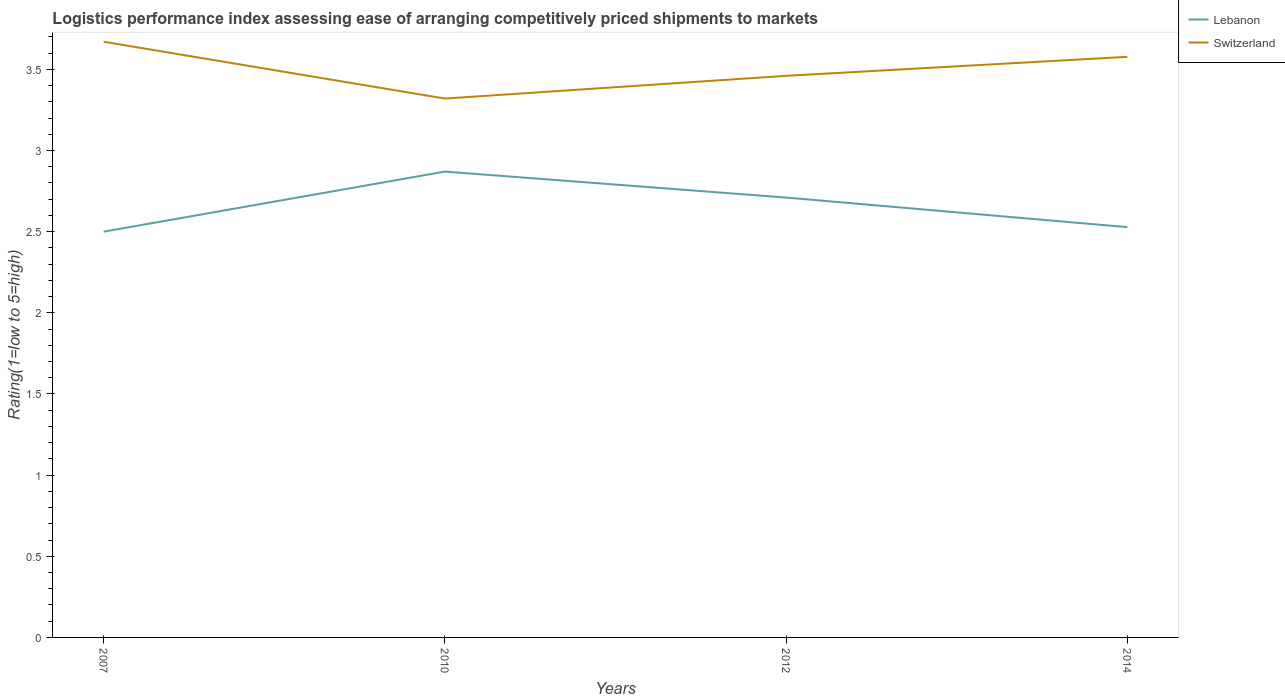How many different coloured lines are there?
Provide a short and direct response. 2. Does the line corresponding to Lebanon intersect with the line corresponding to Switzerland?
Offer a very short reply. No. Is the number of lines equal to the number of legend labels?
Offer a very short reply. Yes. Across all years, what is the maximum Logistic performance index in Lebanon?
Your answer should be very brief. 2.5. What is the total Logistic performance index in Switzerland in the graph?
Your response must be concise. 0.21. What is the difference between the highest and the second highest Logistic performance index in Lebanon?
Your response must be concise. 0.37. What is the difference between the highest and the lowest Logistic performance index in Switzerland?
Provide a succinct answer. 2. Is the Logistic performance index in Switzerland strictly greater than the Logistic performance index in Lebanon over the years?
Your response must be concise. No. How many lines are there?
Offer a very short reply. 2. What is the difference between two consecutive major ticks on the Y-axis?
Your answer should be very brief. 0.5. Where does the legend appear in the graph?
Offer a very short reply. Top right. How many legend labels are there?
Provide a succinct answer. 2. What is the title of the graph?
Keep it short and to the point. Logistics performance index assessing ease of arranging competitively priced shipments to markets. What is the label or title of the X-axis?
Your response must be concise. Years. What is the label or title of the Y-axis?
Your answer should be very brief. Rating(1=low to 5=high). What is the Rating(1=low to 5=high) of Lebanon in 2007?
Provide a short and direct response. 2.5. What is the Rating(1=low to 5=high) in Switzerland in 2007?
Your response must be concise. 3.67. What is the Rating(1=low to 5=high) in Lebanon in 2010?
Offer a very short reply. 2.87. What is the Rating(1=low to 5=high) in Switzerland in 2010?
Give a very brief answer. 3.32. What is the Rating(1=low to 5=high) of Lebanon in 2012?
Your answer should be very brief. 2.71. What is the Rating(1=low to 5=high) in Switzerland in 2012?
Provide a succinct answer. 3.46. What is the Rating(1=low to 5=high) in Lebanon in 2014?
Your response must be concise. 2.53. What is the Rating(1=low to 5=high) of Switzerland in 2014?
Your answer should be compact. 3.58. Across all years, what is the maximum Rating(1=low to 5=high) of Lebanon?
Your response must be concise. 2.87. Across all years, what is the maximum Rating(1=low to 5=high) of Switzerland?
Keep it short and to the point. 3.67. Across all years, what is the minimum Rating(1=low to 5=high) in Lebanon?
Your answer should be compact. 2.5. Across all years, what is the minimum Rating(1=low to 5=high) of Switzerland?
Your answer should be very brief. 3.32. What is the total Rating(1=low to 5=high) in Lebanon in the graph?
Provide a succinct answer. 10.61. What is the total Rating(1=low to 5=high) of Switzerland in the graph?
Ensure brevity in your answer.  14.03. What is the difference between the Rating(1=low to 5=high) in Lebanon in 2007 and that in 2010?
Give a very brief answer. -0.37. What is the difference between the Rating(1=low to 5=high) of Lebanon in 2007 and that in 2012?
Your response must be concise. -0.21. What is the difference between the Rating(1=low to 5=high) in Switzerland in 2007 and that in 2012?
Make the answer very short. 0.21. What is the difference between the Rating(1=low to 5=high) of Lebanon in 2007 and that in 2014?
Provide a short and direct response. -0.03. What is the difference between the Rating(1=low to 5=high) of Switzerland in 2007 and that in 2014?
Offer a terse response. 0.09. What is the difference between the Rating(1=low to 5=high) in Lebanon in 2010 and that in 2012?
Provide a succinct answer. 0.16. What is the difference between the Rating(1=low to 5=high) in Switzerland in 2010 and that in 2012?
Provide a succinct answer. -0.14. What is the difference between the Rating(1=low to 5=high) of Lebanon in 2010 and that in 2014?
Provide a short and direct response. 0.34. What is the difference between the Rating(1=low to 5=high) of Switzerland in 2010 and that in 2014?
Ensure brevity in your answer.  -0.26. What is the difference between the Rating(1=low to 5=high) of Lebanon in 2012 and that in 2014?
Keep it short and to the point. 0.18. What is the difference between the Rating(1=low to 5=high) of Switzerland in 2012 and that in 2014?
Offer a very short reply. -0.12. What is the difference between the Rating(1=low to 5=high) of Lebanon in 2007 and the Rating(1=low to 5=high) of Switzerland in 2010?
Offer a very short reply. -0.82. What is the difference between the Rating(1=low to 5=high) of Lebanon in 2007 and the Rating(1=low to 5=high) of Switzerland in 2012?
Provide a short and direct response. -0.96. What is the difference between the Rating(1=low to 5=high) in Lebanon in 2007 and the Rating(1=low to 5=high) in Switzerland in 2014?
Make the answer very short. -1.08. What is the difference between the Rating(1=low to 5=high) in Lebanon in 2010 and the Rating(1=low to 5=high) in Switzerland in 2012?
Your answer should be very brief. -0.59. What is the difference between the Rating(1=low to 5=high) of Lebanon in 2010 and the Rating(1=low to 5=high) of Switzerland in 2014?
Make the answer very short. -0.71. What is the difference between the Rating(1=low to 5=high) of Lebanon in 2012 and the Rating(1=low to 5=high) of Switzerland in 2014?
Provide a short and direct response. -0.87. What is the average Rating(1=low to 5=high) of Lebanon per year?
Make the answer very short. 2.65. What is the average Rating(1=low to 5=high) in Switzerland per year?
Provide a short and direct response. 3.51. In the year 2007, what is the difference between the Rating(1=low to 5=high) in Lebanon and Rating(1=low to 5=high) in Switzerland?
Offer a terse response. -1.17. In the year 2010, what is the difference between the Rating(1=low to 5=high) in Lebanon and Rating(1=low to 5=high) in Switzerland?
Make the answer very short. -0.45. In the year 2012, what is the difference between the Rating(1=low to 5=high) in Lebanon and Rating(1=low to 5=high) in Switzerland?
Make the answer very short. -0.75. In the year 2014, what is the difference between the Rating(1=low to 5=high) in Lebanon and Rating(1=low to 5=high) in Switzerland?
Your answer should be compact. -1.05. What is the ratio of the Rating(1=low to 5=high) of Lebanon in 2007 to that in 2010?
Ensure brevity in your answer.  0.87. What is the ratio of the Rating(1=low to 5=high) of Switzerland in 2007 to that in 2010?
Offer a terse response. 1.11. What is the ratio of the Rating(1=low to 5=high) in Lebanon in 2007 to that in 2012?
Give a very brief answer. 0.92. What is the ratio of the Rating(1=low to 5=high) in Switzerland in 2007 to that in 2012?
Your answer should be compact. 1.06. What is the ratio of the Rating(1=low to 5=high) of Lebanon in 2010 to that in 2012?
Offer a terse response. 1.06. What is the ratio of the Rating(1=low to 5=high) in Switzerland in 2010 to that in 2012?
Your response must be concise. 0.96. What is the ratio of the Rating(1=low to 5=high) of Lebanon in 2010 to that in 2014?
Your response must be concise. 1.14. What is the ratio of the Rating(1=low to 5=high) in Switzerland in 2010 to that in 2014?
Provide a short and direct response. 0.93. What is the ratio of the Rating(1=low to 5=high) in Lebanon in 2012 to that in 2014?
Provide a succinct answer. 1.07. What is the ratio of the Rating(1=low to 5=high) in Switzerland in 2012 to that in 2014?
Provide a succinct answer. 0.97. What is the difference between the highest and the second highest Rating(1=low to 5=high) of Lebanon?
Ensure brevity in your answer.  0.16. What is the difference between the highest and the second highest Rating(1=low to 5=high) in Switzerland?
Provide a short and direct response. 0.09. What is the difference between the highest and the lowest Rating(1=low to 5=high) in Lebanon?
Offer a terse response. 0.37. What is the difference between the highest and the lowest Rating(1=low to 5=high) of Switzerland?
Your response must be concise. 0.35. 